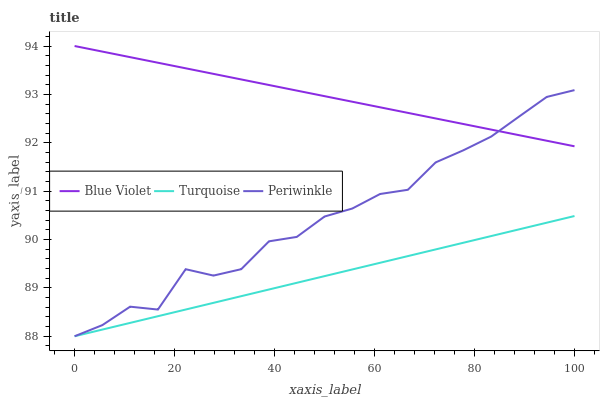Does Turquoise have the minimum area under the curve?
Answer yes or no. Yes. Does Blue Violet have the maximum area under the curve?
Answer yes or no. Yes. Does Periwinkle have the minimum area under the curve?
Answer yes or no. No. Does Periwinkle have the maximum area under the curve?
Answer yes or no. No. Is Blue Violet the smoothest?
Answer yes or no. Yes. Is Periwinkle the roughest?
Answer yes or no. Yes. Is Periwinkle the smoothest?
Answer yes or no. No. Is Blue Violet the roughest?
Answer yes or no. No. Does Turquoise have the lowest value?
Answer yes or no. Yes. Does Blue Violet have the lowest value?
Answer yes or no. No. Does Blue Violet have the highest value?
Answer yes or no. Yes. Does Periwinkle have the highest value?
Answer yes or no. No. Is Turquoise less than Blue Violet?
Answer yes or no. Yes. Is Blue Violet greater than Turquoise?
Answer yes or no. Yes. Does Turquoise intersect Periwinkle?
Answer yes or no. Yes. Is Turquoise less than Periwinkle?
Answer yes or no. No. Is Turquoise greater than Periwinkle?
Answer yes or no. No. Does Turquoise intersect Blue Violet?
Answer yes or no. No. 